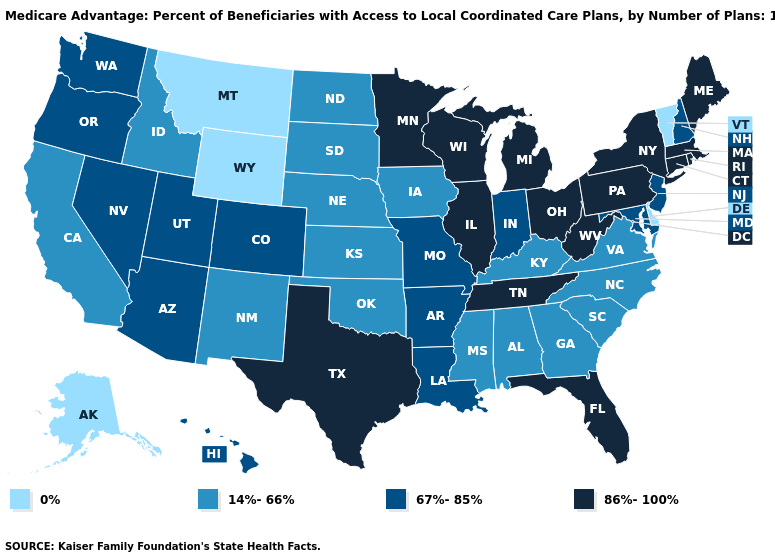Does Montana have the lowest value in the USA?
Short answer required. Yes. Name the states that have a value in the range 86%-100%?
Answer briefly. Connecticut, Florida, Illinois, Massachusetts, Maine, Michigan, Minnesota, New York, Ohio, Pennsylvania, Rhode Island, Tennessee, Texas, Wisconsin, West Virginia. Which states have the highest value in the USA?
Quick response, please. Connecticut, Florida, Illinois, Massachusetts, Maine, Michigan, Minnesota, New York, Ohio, Pennsylvania, Rhode Island, Tennessee, Texas, Wisconsin, West Virginia. What is the lowest value in the West?
Quick response, please. 0%. What is the lowest value in states that border Arizona?
Keep it brief. 14%-66%. Which states have the highest value in the USA?
Keep it brief. Connecticut, Florida, Illinois, Massachusetts, Maine, Michigan, Minnesota, New York, Ohio, Pennsylvania, Rhode Island, Tennessee, Texas, Wisconsin, West Virginia. Does Pennsylvania have the highest value in the USA?
Write a very short answer. Yes. Does the first symbol in the legend represent the smallest category?
Quick response, please. Yes. What is the lowest value in states that border Washington?
Answer briefly. 14%-66%. What is the value of Kentucky?
Answer briefly. 14%-66%. Does Georgia have the highest value in the South?
Quick response, please. No. Name the states that have a value in the range 86%-100%?
Be succinct. Connecticut, Florida, Illinois, Massachusetts, Maine, Michigan, Minnesota, New York, Ohio, Pennsylvania, Rhode Island, Tennessee, Texas, Wisconsin, West Virginia. What is the lowest value in states that border Wisconsin?
Quick response, please. 14%-66%. Does Nevada have a lower value than Ohio?
Be succinct. Yes. What is the value of Nevada?
Write a very short answer. 67%-85%. 